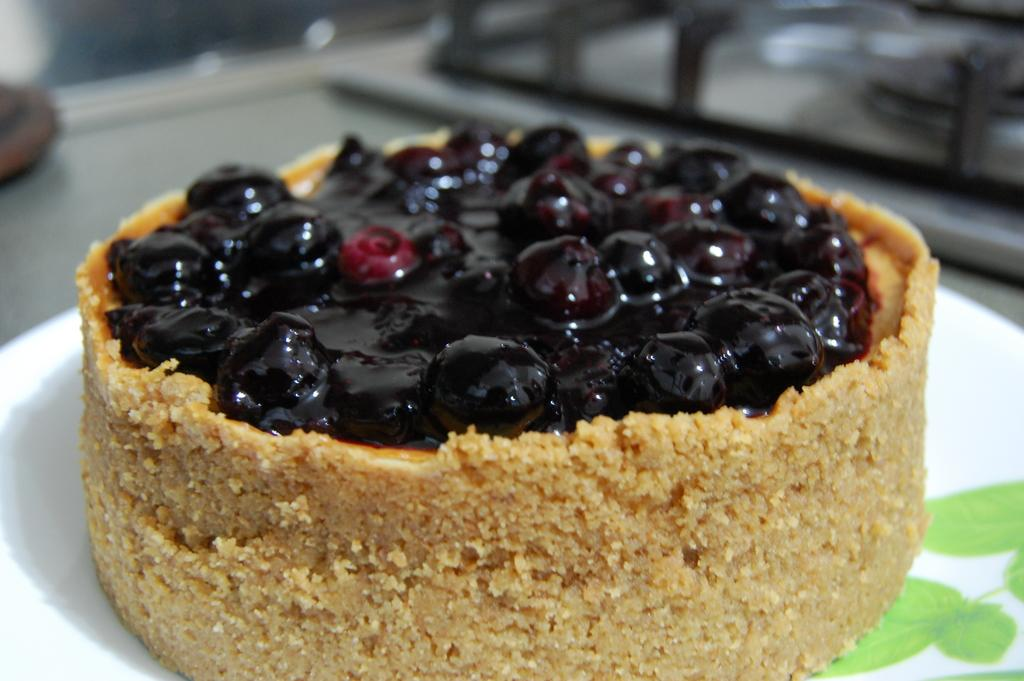What is on the plate in the image? There are food items on a plate in the image. Can you describe the background of the image? The background of the image is blurry. What type of thunder can be heard in the background of the image? There is no thunder present in the image, as it only features a plate with food items and a blurry background. 